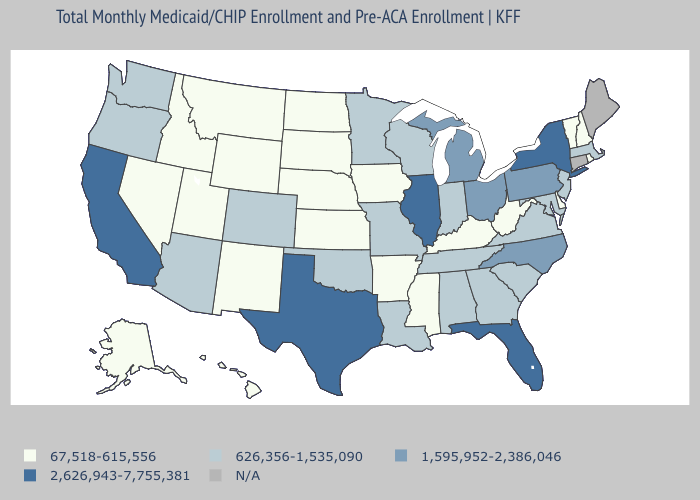Which states have the highest value in the USA?
Keep it brief. California, Florida, Illinois, New York, Texas. Does Rhode Island have the highest value in the USA?
Write a very short answer. No. What is the value of Arizona?
Give a very brief answer. 626,356-1,535,090. What is the value of Massachusetts?
Short answer required. 626,356-1,535,090. What is the value of Arkansas?
Concise answer only. 67,518-615,556. What is the value of Utah?
Be succinct. 67,518-615,556. Which states have the highest value in the USA?
Keep it brief. California, Florida, Illinois, New York, Texas. Among the states that border Montana , which have the highest value?
Quick response, please. Idaho, North Dakota, South Dakota, Wyoming. What is the lowest value in states that border Massachusetts?
Short answer required. 67,518-615,556. What is the lowest value in states that border Arkansas?
Keep it brief. 67,518-615,556. How many symbols are there in the legend?
Write a very short answer. 5. 